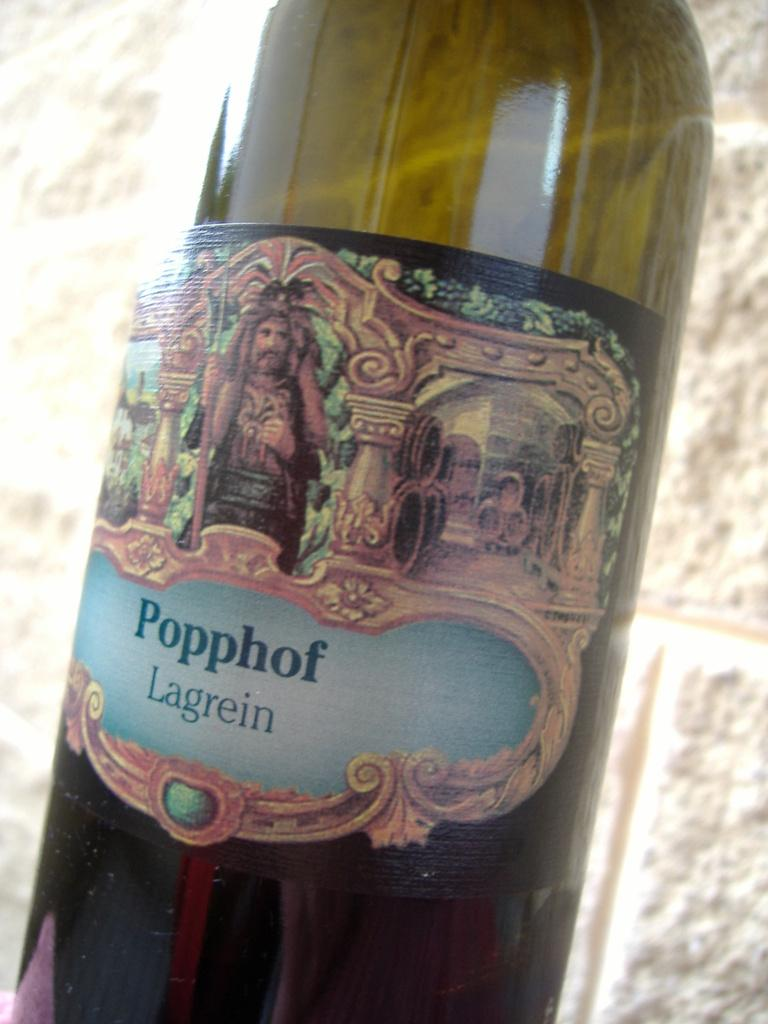<image>
Write a terse but informative summary of the picture. Popphof Lagrein bottle of beer that has a photo of a man on the label. 